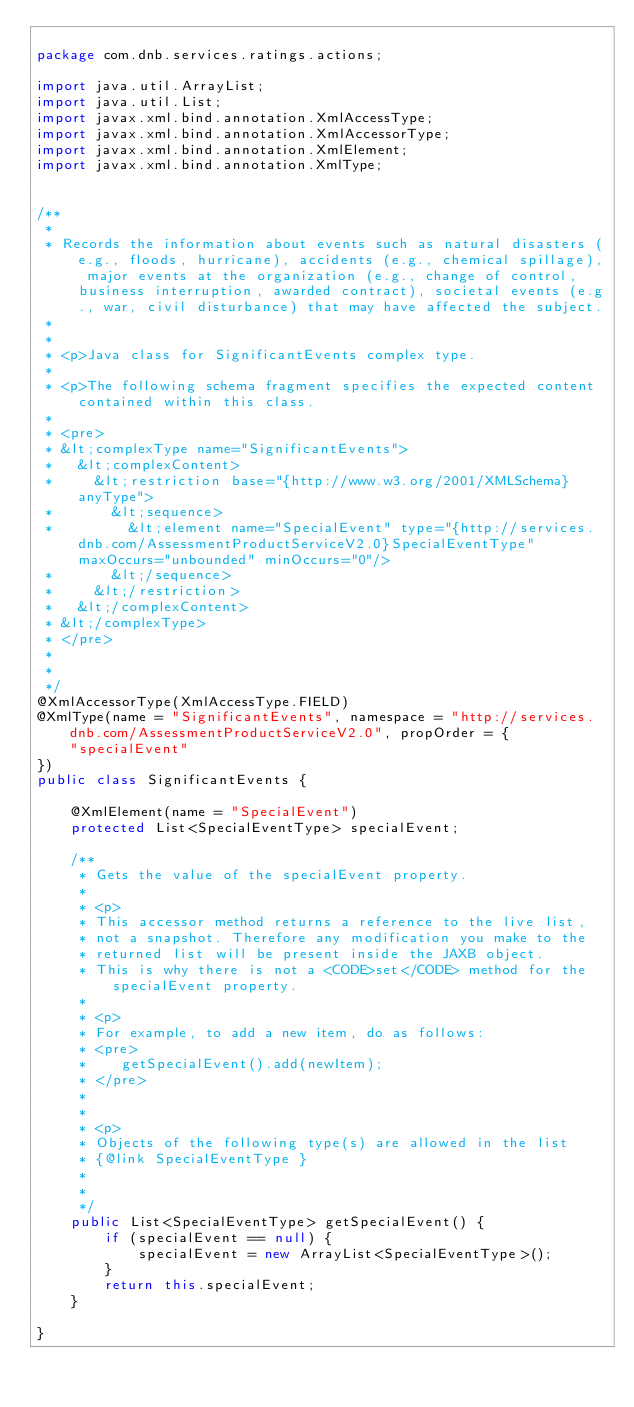Convert code to text. <code><loc_0><loc_0><loc_500><loc_500><_Java_>
package com.dnb.services.ratings.actions;

import java.util.ArrayList;
import java.util.List;
import javax.xml.bind.annotation.XmlAccessType;
import javax.xml.bind.annotation.XmlAccessorType;
import javax.xml.bind.annotation.XmlElement;
import javax.xml.bind.annotation.XmlType;


/**
 * 
 * Records the information about events such as natural disasters (e.g., floods, hurricane), accidents (e.g., chemical spillage), major events at the organization (e.g., change of control, business interruption, awarded contract), societal events (e.g., war, civil disturbance) that may have affected the subject.
 *          
 * 
 * <p>Java class for SignificantEvents complex type.
 * 
 * <p>The following schema fragment specifies the expected content contained within this class.
 * 
 * <pre>
 * &lt;complexType name="SignificantEvents">
 *   &lt;complexContent>
 *     &lt;restriction base="{http://www.w3.org/2001/XMLSchema}anyType">
 *       &lt;sequence>
 *         &lt;element name="SpecialEvent" type="{http://services.dnb.com/AssessmentProductServiceV2.0}SpecialEventType" maxOccurs="unbounded" minOccurs="0"/>
 *       &lt;/sequence>
 *     &lt;/restriction>
 *   &lt;/complexContent>
 * &lt;/complexType>
 * </pre>
 * 
 * 
 */
@XmlAccessorType(XmlAccessType.FIELD)
@XmlType(name = "SignificantEvents", namespace = "http://services.dnb.com/AssessmentProductServiceV2.0", propOrder = {
    "specialEvent"
})
public class SignificantEvents {

    @XmlElement(name = "SpecialEvent")
    protected List<SpecialEventType> specialEvent;

    /**
     * Gets the value of the specialEvent property.
     * 
     * <p>
     * This accessor method returns a reference to the live list,
     * not a snapshot. Therefore any modification you make to the
     * returned list will be present inside the JAXB object.
     * This is why there is not a <CODE>set</CODE> method for the specialEvent property.
     * 
     * <p>
     * For example, to add a new item, do as follows:
     * <pre>
     *    getSpecialEvent().add(newItem);
     * </pre>
     * 
     * 
     * <p>
     * Objects of the following type(s) are allowed in the list
     * {@link SpecialEventType }
     * 
     * 
     */
    public List<SpecialEventType> getSpecialEvent() {
        if (specialEvent == null) {
            specialEvent = new ArrayList<SpecialEventType>();
        }
        return this.specialEvent;
    }

}
</code> 